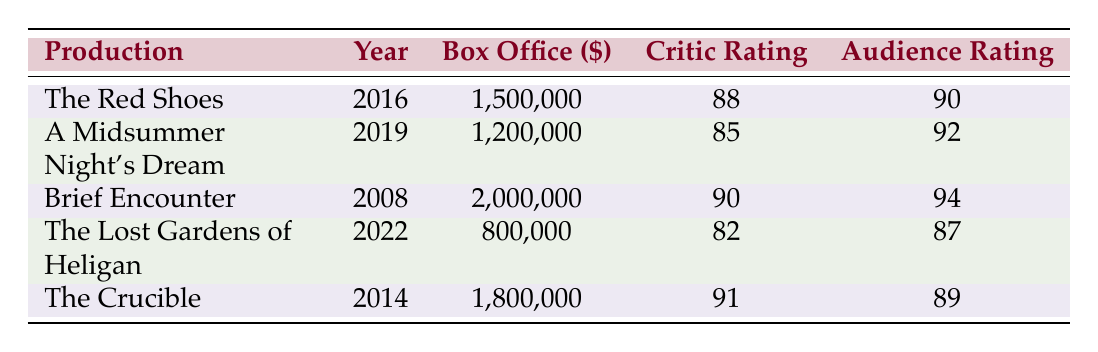What was the box office revenue for "The Red Shoes"? The box office revenue for "The Red Shoes," listed in the table, is clearly stated as 1,500,000.
Answer: 1,500,000 Which production had the highest critic rating? Upon examining the critic ratings in the table, "The Crucible" has the highest rating at 91.
Answer: The Crucible What is the average audience rating of all the productions? To calculate the average audience rating, we sum all audience ratings: (90 + 92 + 94 + 87 + 89) = 452 and then divide by the number of productions, which is 5. So, 452/5 = 90.4.
Answer: 90.4 Did "The Lost Gardens of Heligan" earn more than "A Midsummer Night's Dream"? Comparing their box office revenues, "The Lost Gardens of Heligan" earned 800,000 while "A Midsummer Night's Dream" earned 1,200,000, indicating that "The Lost Gardens of Heligan" earned less.
Answer: No How many productions made over 1,500,000 at the box office? The box office values are 1,500,000 for "The Red Shoes," 2,000,000 for "Brief Encounter," and 1,800,000 for "The Crucible." Thus, three productions exceeded 1,500,000.
Answer: 3 Which production had the lowest audience rating? By checking the audience ratings in the table, "The Lost Gardens of Heligan" had the lowest audience rating, which is 87.
Answer: The Lost Gardens of Heligan What is the total box office revenue for all the productions combined? We sum the box office revenues of all productions as follows: 1,500,000 + 1,200,000 + 2,000,000 + 800,000 + 1,800,000 = 7,300,000.
Answer: 7,300,000 Is it true that all productions have audience ratings above 85? Reviewing the audience ratings, we see that all are above 85 (90, 92, 94, 87, 89), confirming that this statement is true.
Answer: Yes Which production was released most recently? The most recent year listed in the table is 2022, corresponding to "The Lost Gardens of Heligan." Therefore, it was the last production released.
Answer: The Lost Gardens of Heligan 